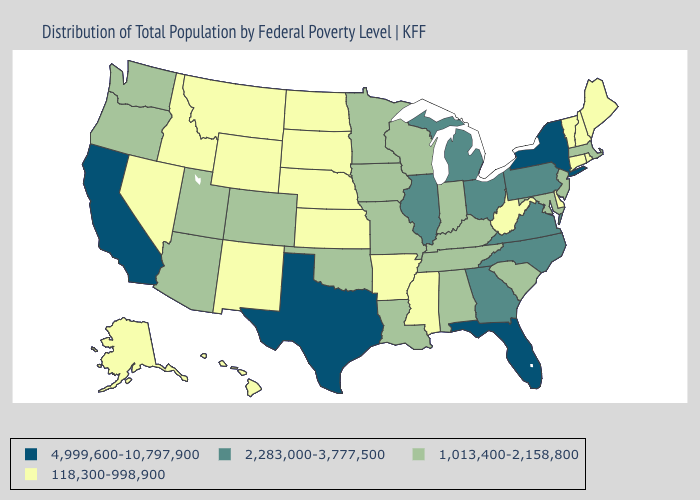What is the value of Washington?
Be succinct. 1,013,400-2,158,800. What is the highest value in states that border Wyoming?
Answer briefly. 1,013,400-2,158,800. Which states hav the highest value in the South?
Concise answer only. Florida, Texas. What is the value of North Carolina?
Write a very short answer. 2,283,000-3,777,500. Does Massachusetts have the lowest value in the USA?
Keep it brief. No. Which states have the lowest value in the USA?
Keep it brief. Alaska, Arkansas, Connecticut, Delaware, Hawaii, Idaho, Kansas, Maine, Mississippi, Montana, Nebraska, Nevada, New Hampshire, New Mexico, North Dakota, Rhode Island, South Dakota, Vermont, West Virginia, Wyoming. Does Massachusetts have a higher value than West Virginia?
Give a very brief answer. Yes. Name the states that have a value in the range 1,013,400-2,158,800?
Concise answer only. Alabama, Arizona, Colorado, Indiana, Iowa, Kentucky, Louisiana, Maryland, Massachusetts, Minnesota, Missouri, New Jersey, Oklahoma, Oregon, South Carolina, Tennessee, Utah, Washington, Wisconsin. Name the states that have a value in the range 2,283,000-3,777,500?
Quick response, please. Georgia, Illinois, Michigan, North Carolina, Ohio, Pennsylvania, Virginia. What is the value of Iowa?
Answer briefly. 1,013,400-2,158,800. What is the lowest value in states that border Kentucky?
Answer briefly. 118,300-998,900. Which states have the lowest value in the Northeast?
Keep it brief. Connecticut, Maine, New Hampshire, Rhode Island, Vermont. Does the first symbol in the legend represent the smallest category?
Write a very short answer. No. Does the first symbol in the legend represent the smallest category?
Short answer required. No. Among the states that border Arizona , which have the lowest value?
Write a very short answer. Nevada, New Mexico. 